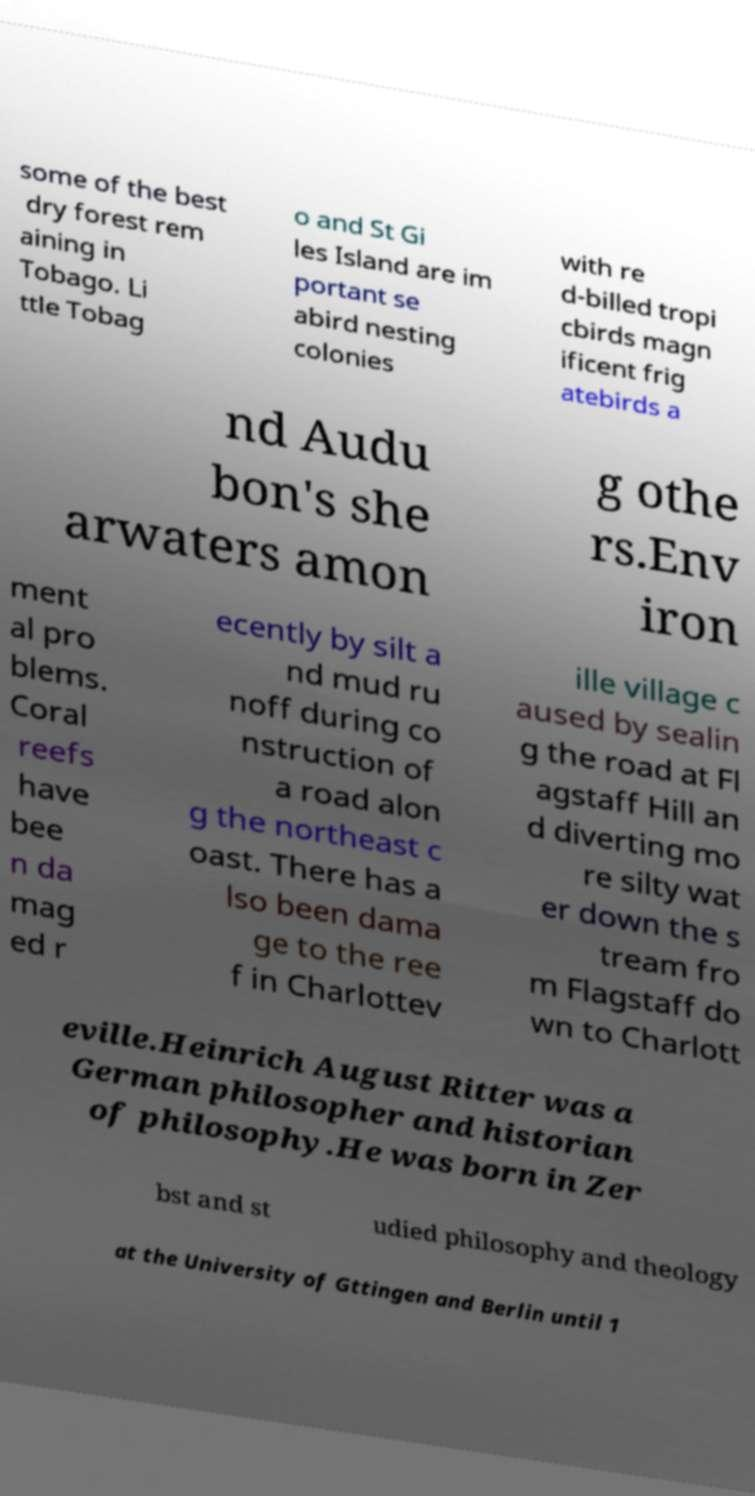Could you assist in decoding the text presented in this image and type it out clearly? some of the best dry forest rem aining in Tobago. Li ttle Tobag o and St Gi les Island are im portant se abird nesting colonies with re d-billed tropi cbirds magn ificent frig atebirds a nd Audu bon's she arwaters amon g othe rs.Env iron ment al pro blems. Coral reefs have bee n da mag ed r ecently by silt a nd mud ru noff during co nstruction of a road alon g the northeast c oast. There has a lso been dama ge to the ree f in Charlottev ille village c aused by sealin g the road at Fl agstaff Hill an d diverting mo re silty wat er down the s tream fro m Flagstaff do wn to Charlott eville.Heinrich August Ritter was a German philosopher and historian of philosophy.He was born in Zer bst and st udied philosophy and theology at the University of Gttingen and Berlin until 1 